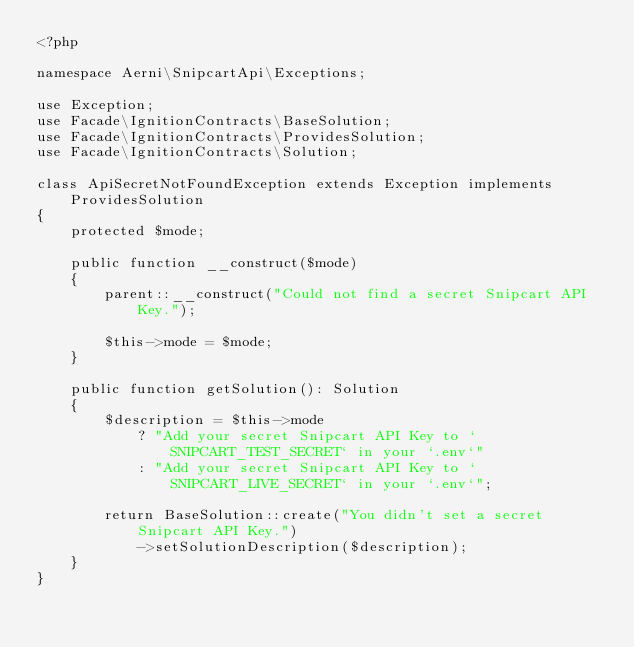Convert code to text. <code><loc_0><loc_0><loc_500><loc_500><_PHP_><?php

namespace Aerni\SnipcartApi\Exceptions;

use Exception;
use Facade\IgnitionContracts\BaseSolution;
use Facade\IgnitionContracts\ProvidesSolution;
use Facade\IgnitionContracts\Solution;

class ApiSecretNotFoundException extends Exception implements ProvidesSolution
{
    protected $mode;

    public function __construct($mode)
    {
        parent::__construct("Could not find a secret Snipcart API Key.");

        $this->mode = $mode;
    }

    public function getSolution(): Solution
    {
        $description = $this->mode
            ? "Add your secret Snipcart API Key to `SNIPCART_TEST_SECRET` in your `.env`"
            : "Add your secret Snipcart API Key to `SNIPCART_LIVE_SECRET` in your `.env`";

        return BaseSolution::create("You didn't set a secret Snipcart API Key.")
            ->setSolutionDescription($description);
    }
}
</code> 